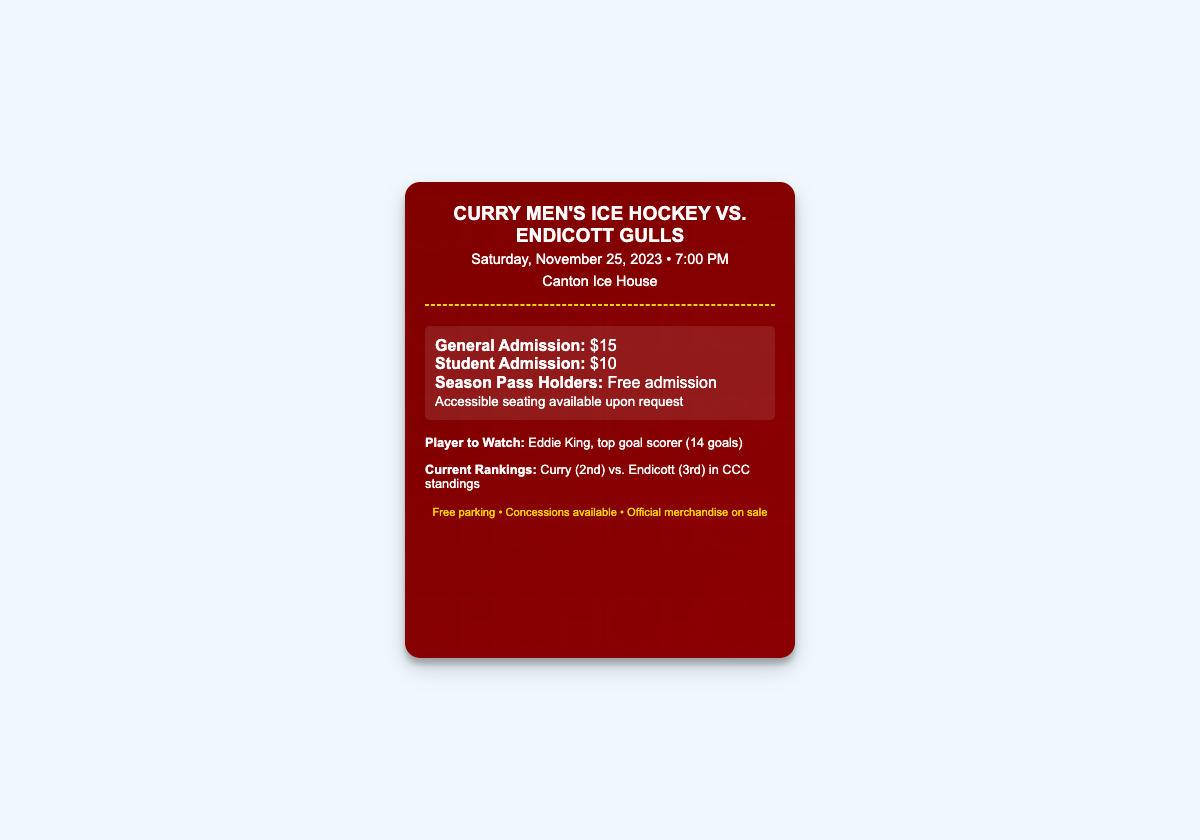What is the date of the game? The date of the game is specified in the document as Saturday, November 25, 2023.
Answer: Saturday, November 25, 2023 What time does the game start? The start time of the game is mentioned in the document. It is at 7:00 PM.
Answer: 7:00 PM What venue is hosting the game? The venue for the game is indicated in the header section. It is the Canton Ice House.
Answer: Canton Ice House How much is general admission? The document provides specific pricing for general admission, which is $15.
Answer: $15 Who is the player to watch? The document highlights a specific player, Eddie King, who is noted as the top goal scorer.
Answer: Eddie King What is Curry's current ranking? The current rankings are listed in the highlights section, showing Curry is in 2nd place.
Answer: 2nd How much is student admission? The price for student admission is specifically stated in the document as $10.
Answer: $10 Is accessible seating available? The document mentions that accessible seating is available upon request.
Answer: Yes What additional amenities are mentioned for the event? The document specifies amenities such as free parking, concessions, and merchandise on sale.
Answer: Free parking, concessions, merchandise 